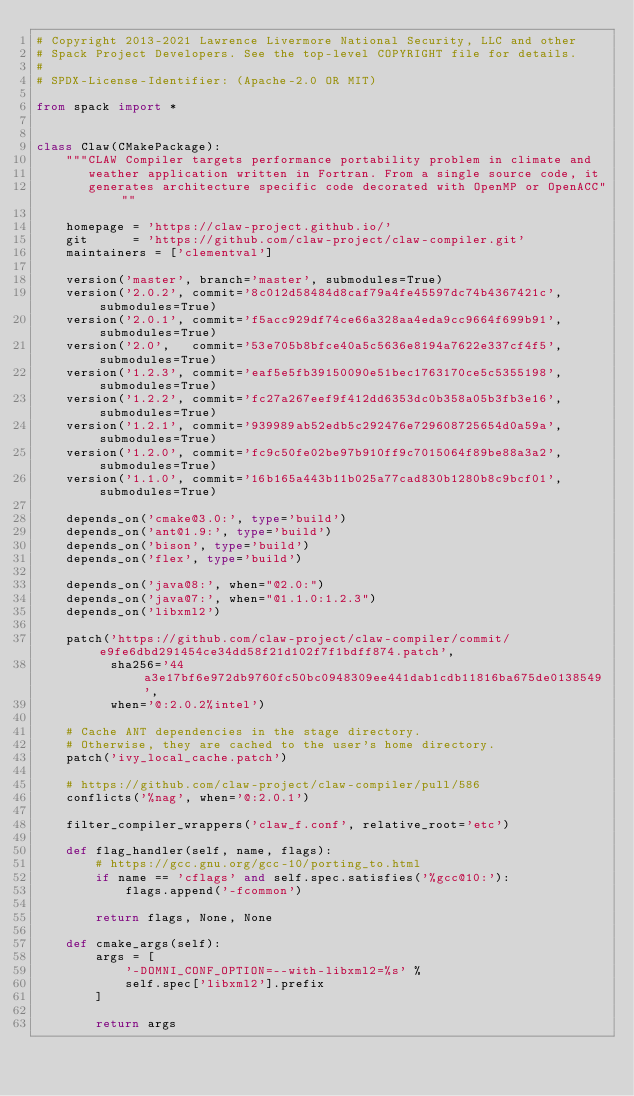Convert code to text. <code><loc_0><loc_0><loc_500><loc_500><_Python_># Copyright 2013-2021 Lawrence Livermore National Security, LLC and other
# Spack Project Developers. See the top-level COPYRIGHT file for details.
#
# SPDX-License-Identifier: (Apache-2.0 OR MIT)

from spack import *


class Claw(CMakePackage):
    """CLAW Compiler targets performance portability problem in climate and
       weather application written in Fortran. From a single source code, it
       generates architecture specific code decorated with OpenMP or OpenACC"""

    homepage = 'https://claw-project.github.io/'
    git      = 'https://github.com/claw-project/claw-compiler.git'
    maintainers = ['clementval']

    version('master', branch='master', submodules=True)
    version('2.0.2', commit='8c012d58484d8caf79a4fe45597dc74b4367421c', submodules=True)
    version('2.0.1', commit='f5acc929df74ce66a328aa4eda9cc9664f699b91', submodules=True)
    version('2.0',   commit='53e705b8bfce40a5c5636e8194a7622e337cf4f5', submodules=True)
    version('1.2.3', commit='eaf5e5fb39150090e51bec1763170ce5c5355198', submodules=True)
    version('1.2.2', commit='fc27a267eef9f412dd6353dc0b358a05b3fb3e16', submodules=True)
    version('1.2.1', commit='939989ab52edb5c292476e729608725654d0a59a', submodules=True)
    version('1.2.0', commit='fc9c50fe02be97b910ff9c7015064f89be88a3a2', submodules=True)
    version('1.1.0', commit='16b165a443b11b025a77cad830b1280b8c9bcf01', submodules=True)

    depends_on('cmake@3.0:', type='build')
    depends_on('ant@1.9:', type='build')
    depends_on('bison', type='build')
    depends_on('flex', type='build')

    depends_on('java@8:', when="@2.0:")
    depends_on('java@7:', when="@1.1.0:1.2.3")
    depends_on('libxml2')

    patch('https://github.com/claw-project/claw-compiler/commit/e9fe6dbd291454ce34dd58f21d102f7f1bdff874.patch',
          sha256='44a3e17bf6e972db9760fc50bc0948309ee441dab1cdb11816ba675de0138549',
          when='@:2.0.2%intel')

    # Cache ANT dependencies in the stage directory.
    # Otherwise, they are cached to the user's home directory.
    patch('ivy_local_cache.patch')

    # https://github.com/claw-project/claw-compiler/pull/586
    conflicts('%nag', when='@:2.0.1')

    filter_compiler_wrappers('claw_f.conf', relative_root='etc')

    def flag_handler(self, name, flags):
        # https://gcc.gnu.org/gcc-10/porting_to.html
        if name == 'cflags' and self.spec.satisfies('%gcc@10:'):
            flags.append('-fcommon')

        return flags, None, None

    def cmake_args(self):
        args = [
            '-DOMNI_CONF_OPTION=--with-libxml2=%s' %
            self.spec['libxml2'].prefix
        ]

        return args
</code> 